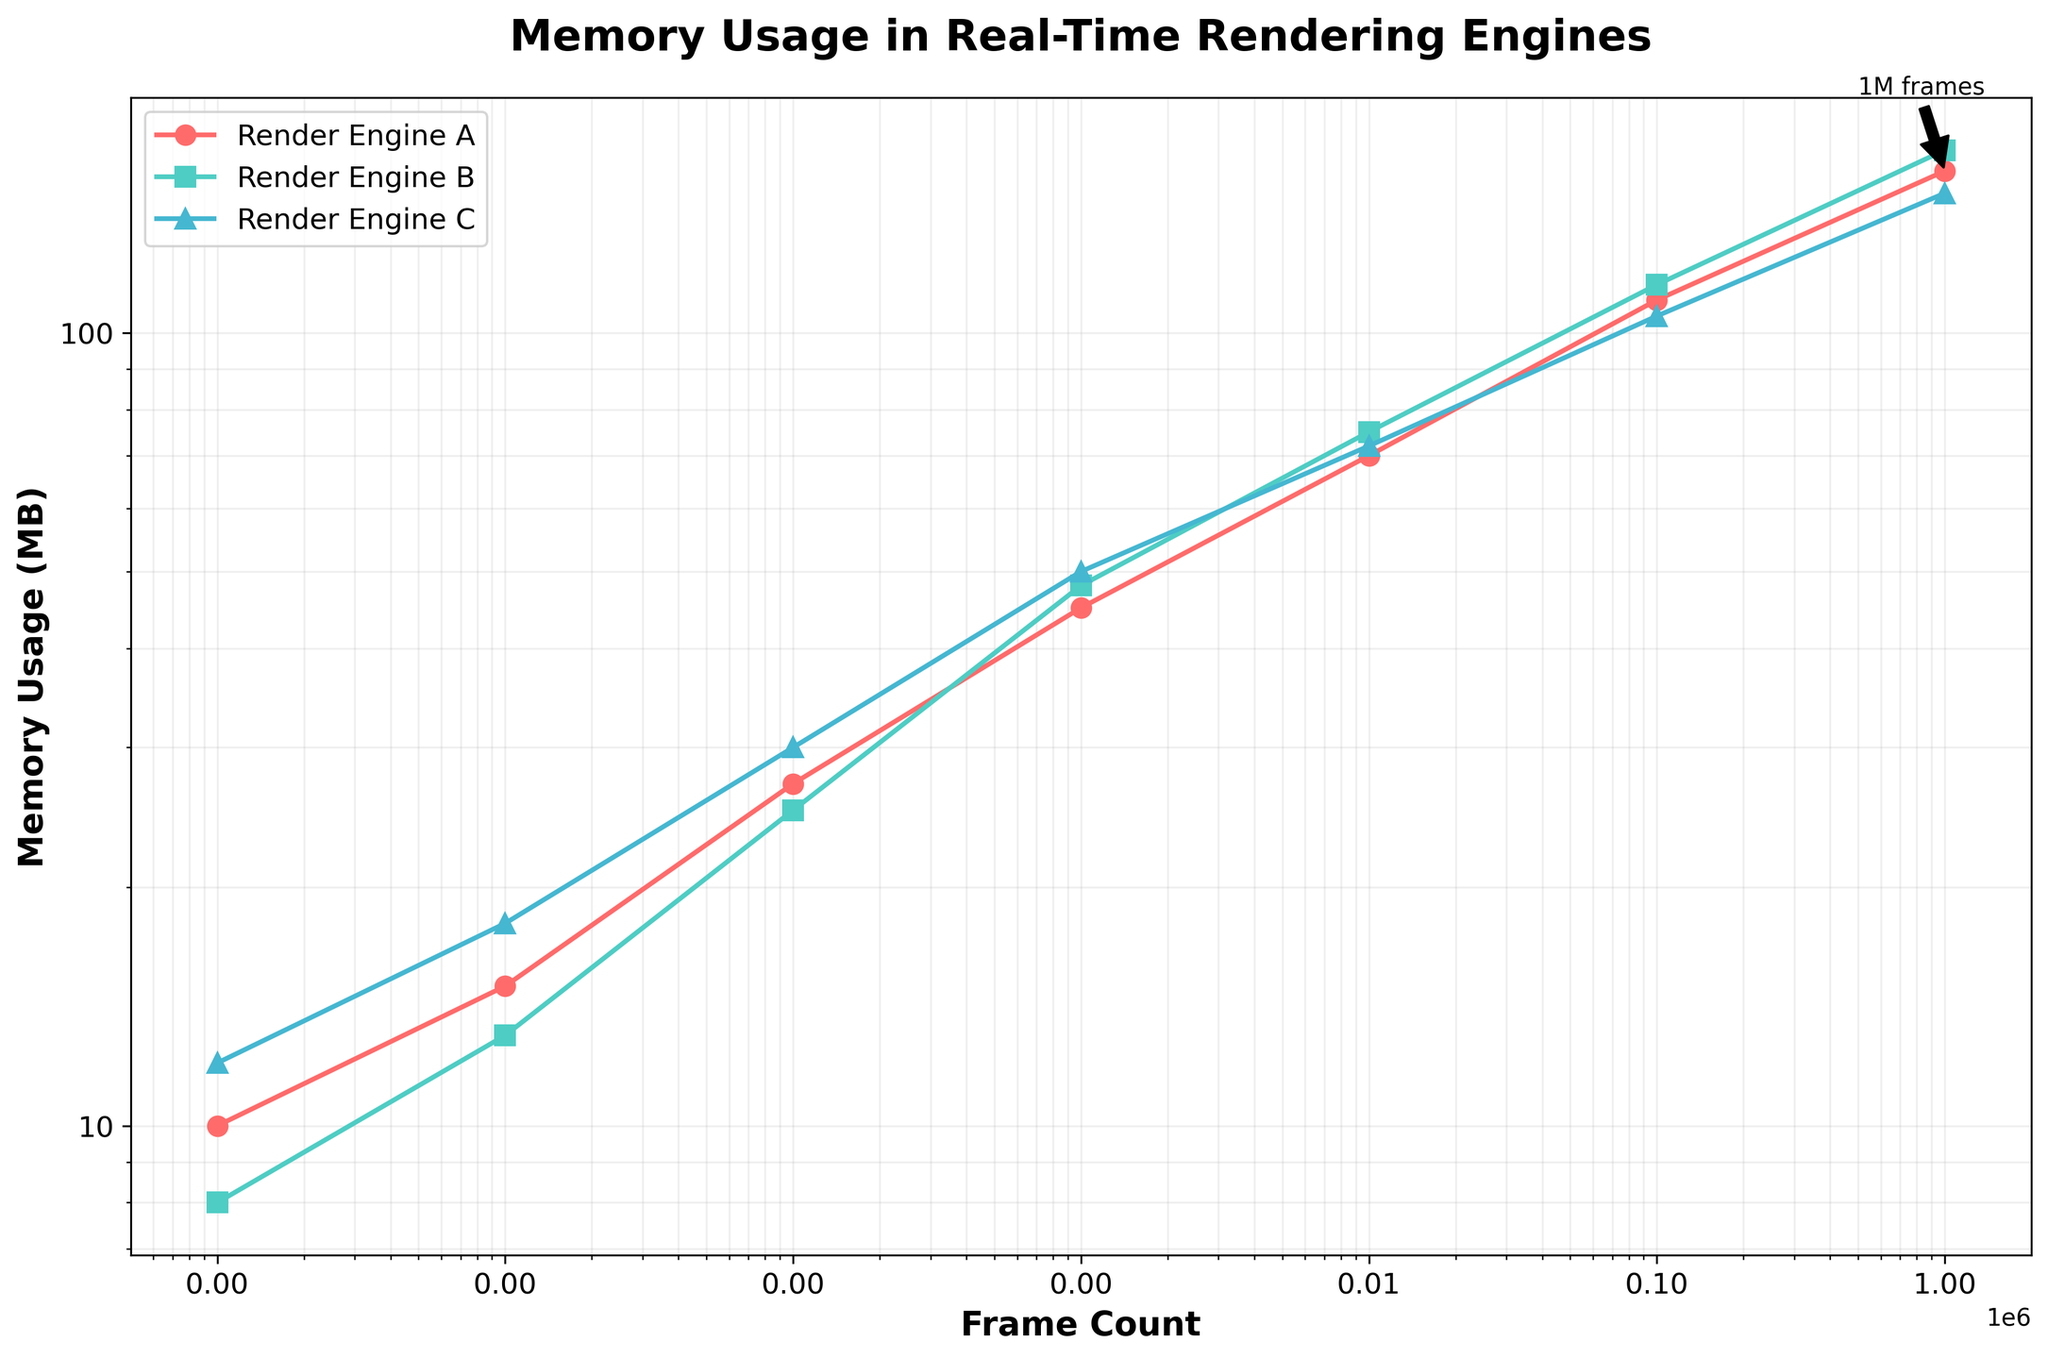What's the title of the figure? The title is shown at the top of the figure.
Answer: Memory Usage in Real-Time Rendering Engines What are the labels on the x-axis and y-axis? The x-axis label is situated beneath the horizontal axis, and the y-axis label is alongside the vertical axis.
Answer: Frame Count (x-axis) and Memory Usage (MB) (y-axis) How many data points are plotted for Render Engine A? Count the number of markers (points) on the plot for Render Engine A, which can be identified by their color (#FF6B6B).
Answer: 7 Which Render Engine shows the highest memory usage at 100,000 frames? Look for the y-values corresponding to 100,000 frames on the x-axis for all three engines; compare the three values.
Answer: Render Engine B (115 MB) What is the minimum memory usage recorded for Render Engine C, and at which frame count does it occur? Find the lowest y-value for Render Engine C's data points and determine the corresponding x-value for that point.
Answer: 12 MB at 1 frame Which Render Engine has the steepest increase in memory usage between 1 and 100 frames? Compare the slopes of the lines between the points for each engine from 1 to 100 frames. Steepest slope indicates the largest increase.
Answer: Render Engine C For which frame count is there the largest memory usage difference between Render Engine A and B? And what is that difference? Calculate the pairwise differences between A and B for each frame count and identify the maximum difference.
Answer: Largest difference: 10 MB at 1,000,000 frames How does the memory usage trend for Render Engine A compare to Render Engine C over the entire frame range? Evaluate whether the curve for Render Engine A is consistently above, below, or crossing the curve for Render Engine C across the plotted frame counts.
Answer: Render Engine A starts lower but ends higher than Render Engine C Is the scaling of the axes linear or logarithmic, and what visual evidence supports this? Examine the tick marks and their spacing, which should increase exponentially if the scale is logarithmic.
Answer: Logarithmic, as the spacing between ticks increases exponentially What annotation is present on the plot, and what does it indicate? Look for any text or markers highlighting specific data points, such as annotations with arrows.
Answer: An annotation marks "1M frames" at 1,000,000 frames with memory usage indicated for Render Engine A (160 MB) 